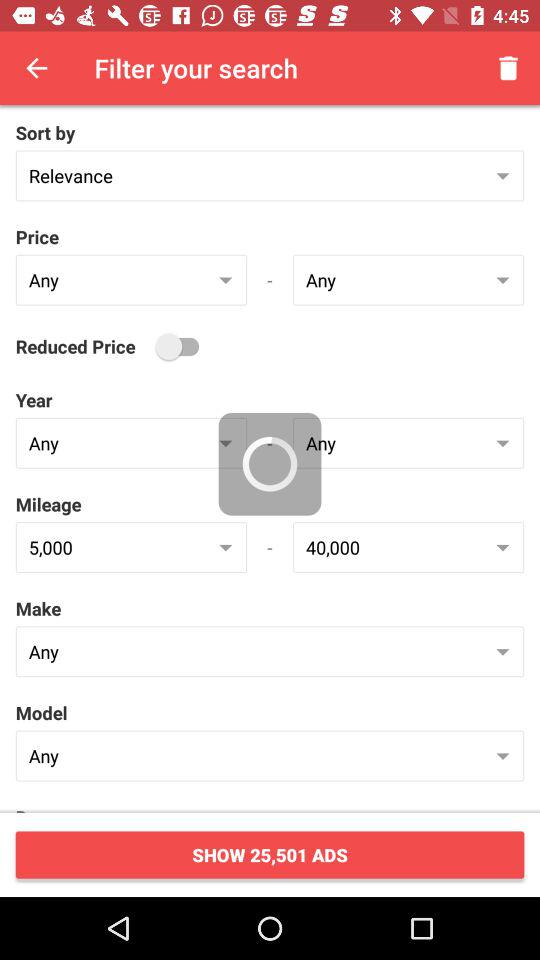What is the selected model? The selected model is "Any". 